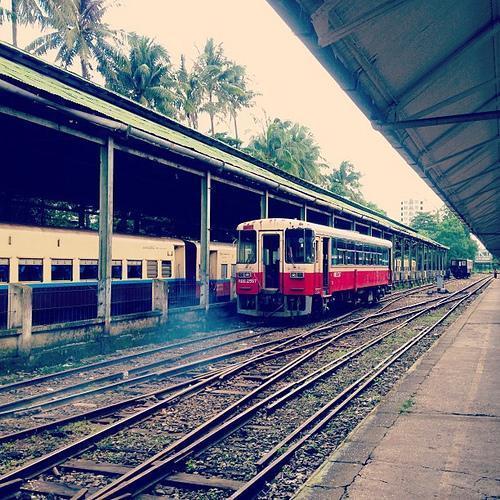How many trains are in this picture?
Give a very brief answer. 3. How many people are in this photo?
Give a very brief answer. 0. 